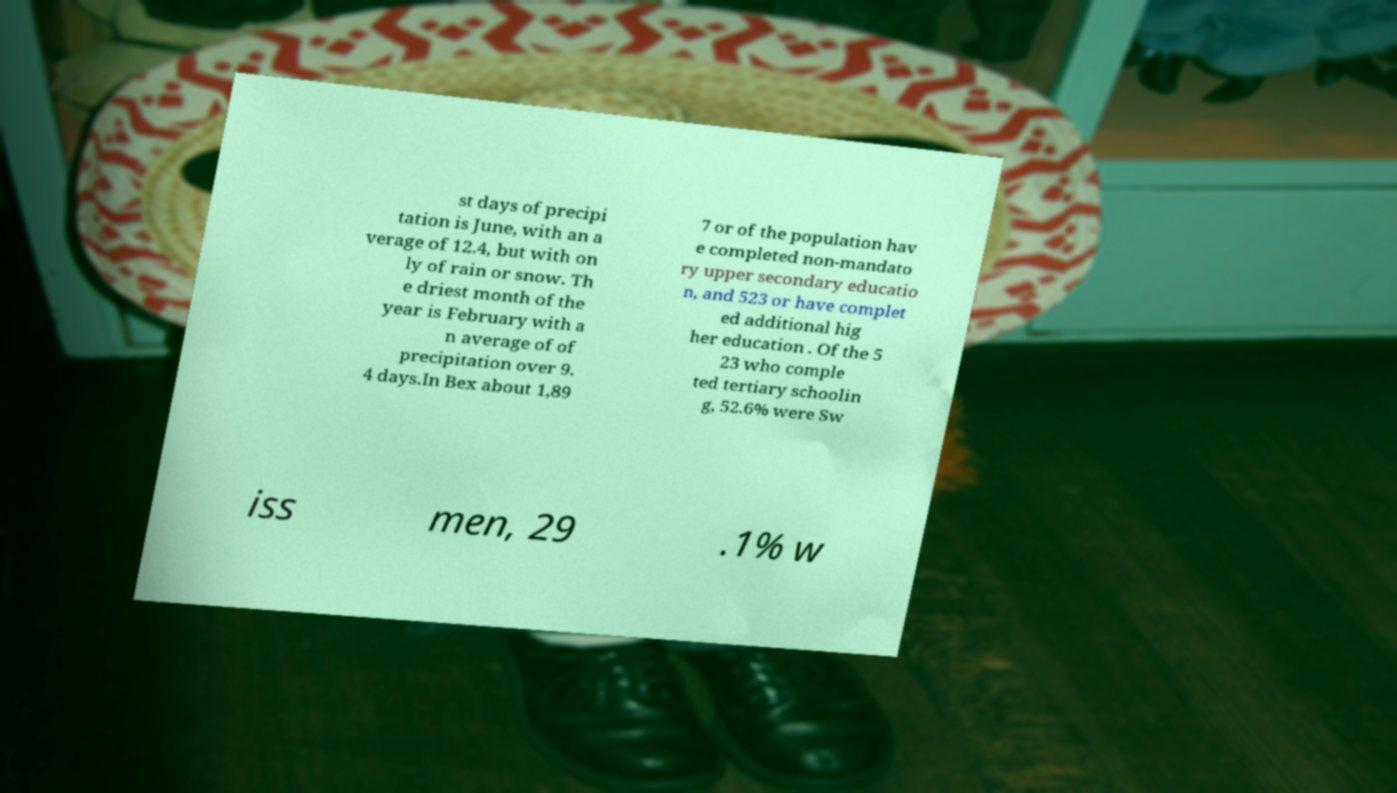Can you read and provide the text displayed in the image?This photo seems to have some interesting text. Can you extract and type it out for me? st days of precipi tation is June, with an a verage of 12.4, but with on ly of rain or snow. Th e driest month of the year is February with a n average of of precipitation over 9. 4 days.In Bex about 1,89 7 or of the population hav e completed non-mandato ry upper secondary educatio n, and 523 or have complet ed additional hig her education . Of the 5 23 who comple ted tertiary schoolin g, 52.6% were Sw iss men, 29 .1% w 